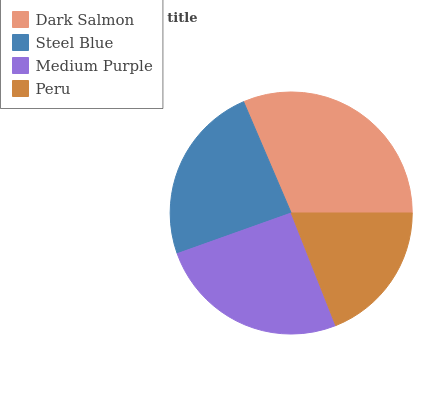Is Peru the minimum?
Answer yes or no. Yes. Is Dark Salmon the maximum?
Answer yes or no. Yes. Is Steel Blue the minimum?
Answer yes or no. No. Is Steel Blue the maximum?
Answer yes or no. No. Is Dark Salmon greater than Steel Blue?
Answer yes or no. Yes. Is Steel Blue less than Dark Salmon?
Answer yes or no. Yes. Is Steel Blue greater than Dark Salmon?
Answer yes or no. No. Is Dark Salmon less than Steel Blue?
Answer yes or no. No. Is Medium Purple the high median?
Answer yes or no. Yes. Is Steel Blue the low median?
Answer yes or no. Yes. Is Peru the high median?
Answer yes or no. No. Is Medium Purple the low median?
Answer yes or no. No. 